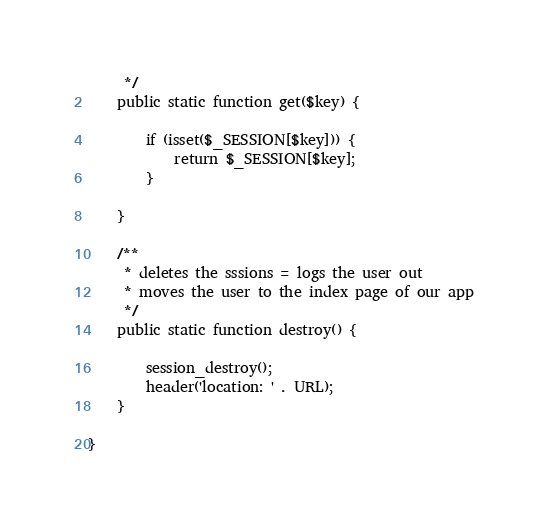Convert code to text. <code><loc_0><loc_0><loc_500><loc_500><_PHP_>     */
    public static function get($key) {
        
        if (isset($_SESSION[$key])) {
            return $_SESSION[$key];
        }
            
    }

    /**
     * deletes the sssions = logs the user out
     * moves the user to the index page of our app
     */
    public static function destroy() {
        
        session_destroy();
        header('location: ' . URL);
    }

}</code> 